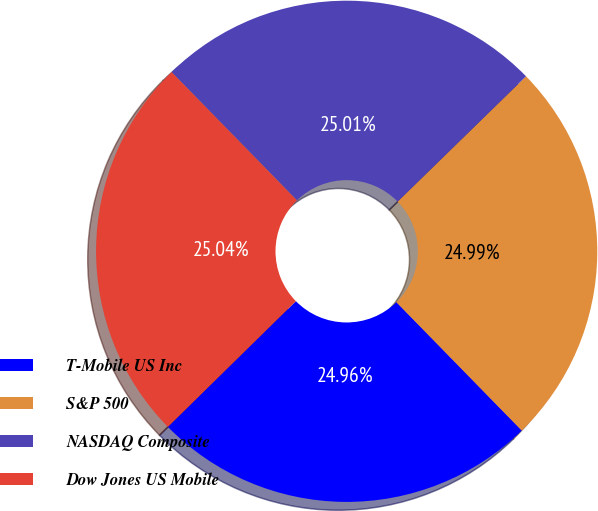<chart> <loc_0><loc_0><loc_500><loc_500><pie_chart><fcel>T-Mobile US Inc<fcel>S&P 500<fcel>NASDAQ Composite<fcel>Dow Jones US Mobile<nl><fcel>24.96%<fcel>24.99%<fcel>25.01%<fcel>25.04%<nl></chart> 